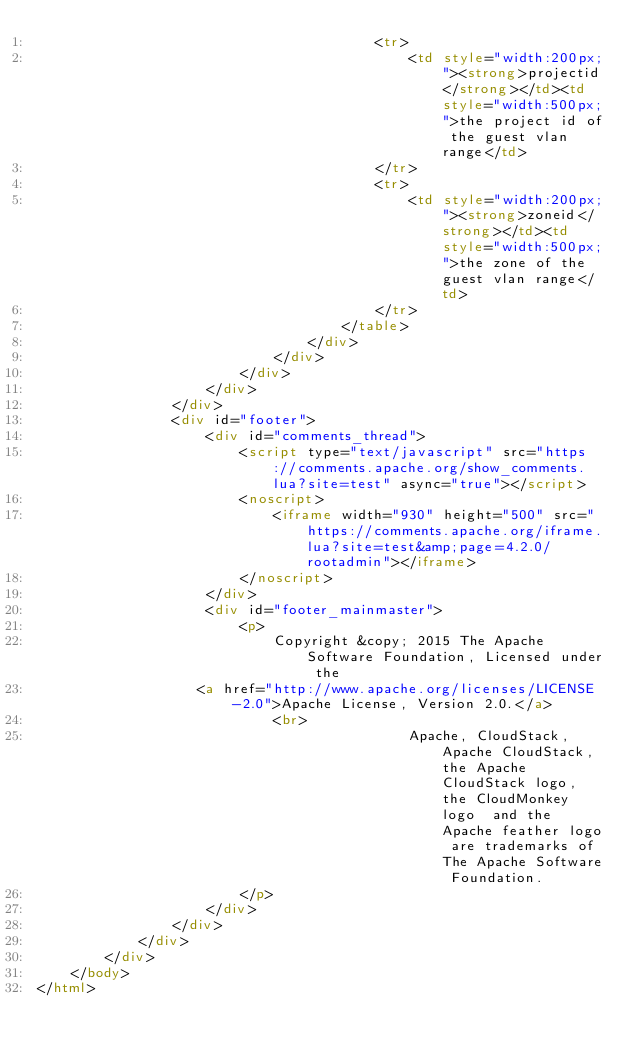Convert code to text. <code><loc_0><loc_0><loc_500><loc_500><_HTML_>                                        <tr>
                                            <td style="width:200px;"><strong>projectid</strong></td><td style="width:500px;">the project id of the guest vlan range</td>
                                        </tr>
                                        <tr>
                                            <td style="width:200px;"><strong>zoneid</strong></td><td style="width:500px;">the zone of the guest vlan range</td>
                                        </tr>
                                    </table>
                                </div>
                            </div>
                        </div>
                    </div>
                </div>
                <div id="footer">
                    <div id="comments_thread">
                        <script type="text/javascript" src="https://comments.apache.org/show_comments.lua?site=test" async="true"></script>
                        <noscript>
                            <iframe width="930" height="500" src="https://comments.apache.org/iframe.lua?site=test&amp;page=4.2.0/rootadmin"></iframe>
                        </noscript>
                    </div>
                    <div id="footer_mainmaster">
                        <p>
                            Copyright &copy; 2015 The Apache Software Foundation, Licensed under the
                   <a href="http://www.apache.org/licenses/LICENSE-2.0">Apache License, Version 2.0.</a>
                            <br>
                                            Apache, CloudStack, Apache CloudStack, the Apache CloudStack logo, the CloudMonkey logo  and the Apache feather logo are trademarks of The Apache Software Foundation.
                        </p>
                    </div>
                </div>
            </div>
        </div>
    </body>
</html>
</code> 